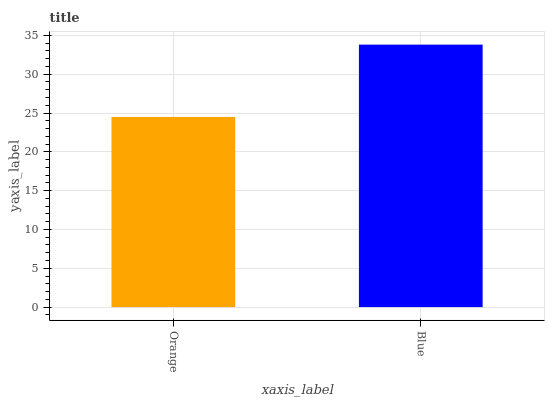Is Blue the minimum?
Answer yes or no. No. Is Blue greater than Orange?
Answer yes or no. Yes. Is Orange less than Blue?
Answer yes or no. Yes. Is Orange greater than Blue?
Answer yes or no. No. Is Blue less than Orange?
Answer yes or no. No. Is Blue the high median?
Answer yes or no. Yes. Is Orange the low median?
Answer yes or no. Yes. Is Orange the high median?
Answer yes or no. No. Is Blue the low median?
Answer yes or no. No. 